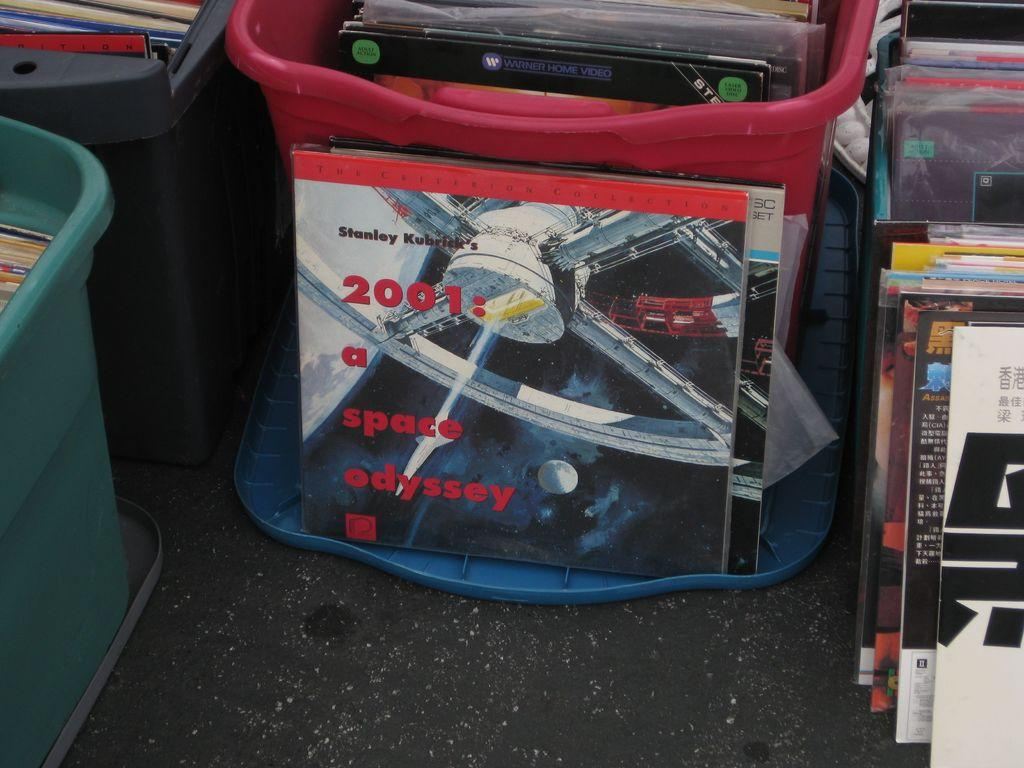What objects are present in the image? There are boxes in the image. What is placed on top of the boxes? There are books on the boxes. Can you read any text on the books? Yes, there is text visible on the books. How many chickens are sitting on the books in the image? There are no chickens present in the image; it only features boxes and books. What color is the ball on top of the books? There is no ball present in the image; it only features boxes and books. 